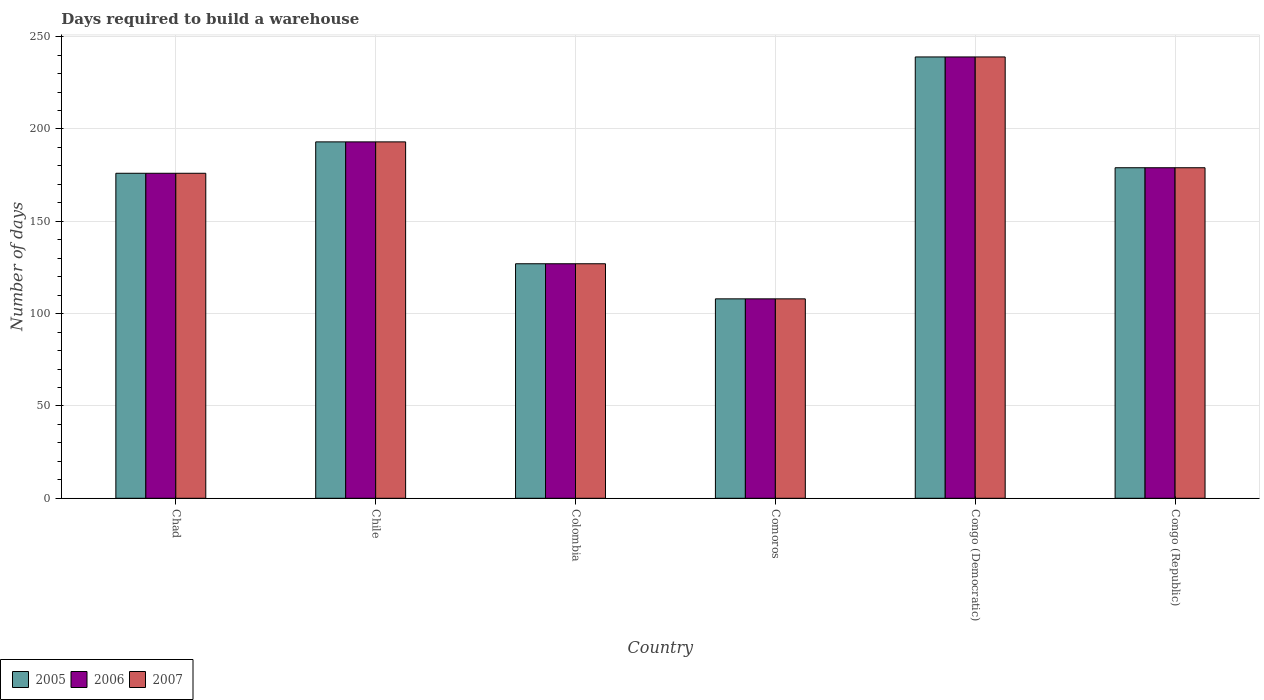How many different coloured bars are there?
Ensure brevity in your answer.  3. How many groups of bars are there?
Your response must be concise. 6. How many bars are there on the 4th tick from the left?
Your answer should be compact. 3. How many bars are there on the 6th tick from the right?
Your answer should be very brief. 3. What is the label of the 2nd group of bars from the left?
Provide a short and direct response. Chile. In how many cases, is the number of bars for a given country not equal to the number of legend labels?
Your response must be concise. 0. What is the days required to build a warehouse in in 2006 in Chile?
Keep it short and to the point. 193. Across all countries, what is the maximum days required to build a warehouse in in 2006?
Provide a succinct answer. 239. Across all countries, what is the minimum days required to build a warehouse in in 2005?
Provide a succinct answer. 108. In which country was the days required to build a warehouse in in 2007 maximum?
Give a very brief answer. Congo (Democratic). In which country was the days required to build a warehouse in in 2006 minimum?
Offer a terse response. Comoros. What is the total days required to build a warehouse in in 2005 in the graph?
Your answer should be compact. 1022. What is the difference between the days required to build a warehouse in in 2007 in Congo (Republic) and the days required to build a warehouse in in 2005 in Congo (Democratic)?
Provide a succinct answer. -60. What is the average days required to build a warehouse in in 2005 per country?
Provide a succinct answer. 170.33. What is the difference between the days required to build a warehouse in of/in 2007 and days required to build a warehouse in of/in 2006 in Colombia?
Give a very brief answer. 0. What is the ratio of the days required to build a warehouse in in 2006 in Chad to that in Colombia?
Your answer should be compact. 1.39. Is the days required to build a warehouse in in 2005 in Colombia less than that in Congo (Republic)?
Give a very brief answer. Yes. What is the difference between the highest and the lowest days required to build a warehouse in in 2006?
Your response must be concise. 131. In how many countries, is the days required to build a warehouse in in 2005 greater than the average days required to build a warehouse in in 2005 taken over all countries?
Offer a very short reply. 4. What does the 3rd bar from the left in Chile represents?
Offer a very short reply. 2007. What does the 3rd bar from the right in Chile represents?
Your response must be concise. 2005. Are all the bars in the graph horizontal?
Offer a terse response. No. Where does the legend appear in the graph?
Make the answer very short. Bottom left. How are the legend labels stacked?
Make the answer very short. Horizontal. What is the title of the graph?
Provide a succinct answer. Days required to build a warehouse. Does "2002" appear as one of the legend labels in the graph?
Keep it short and to the point. No. What is the label or title of the Y-axis?
Provide a succinct answer. Number of days. What is the Number of days of 2005 in Chad?
Offer a terse response. 176. What is the Number of days in 2006 in Chad?
Provide a short and direct response. 176. What is the Number of days in 2007 in Chad?
Provide a short and direct response. 176. What is the Number of days in 2005 in Chile?
Provide a short and direct response. 193. What is the Number of days in 2006 in Chile?
Ensure brevity in your answer.  193. What is the Number of days in 2007 in Chile?
Your answer should be very brief. 193. What is the Number of days in 2005 in Colombia?
Offer a very short reply. 127. What is the Number of days of 2006 in Colombia?
Make the answer very short. 127. What is the Number of days of 2007 in Colombia?
Your answer should be very brief. 127. What is the Number of days of 2005 in Comoros?
Your answer should be compact. 108. What is the Number of days in 2006 in Comoros?
Your answer should be very brief. 108. What is the Number of days of 2007 in Comoros?
Your response must be concise. 108. What is the Number of days in 2005 in Congo (Democratic)?
Make the answer very short. 239. What is the Number of days in 2006 in Congo (Democratic)?
Offer a very short reply. 239. What is the Number of days in 2007 in Congo (Democratic)?
Provide a short and direct response. 239. What is the Number of days of 2005 in Congo (Republic)?
Your answer should be very brief. 179. What is the Number of days of 2006 in Congo (Republic)?
Your answer should be compact. 179. What is the Number of days in 2007 in Congo (Republic)?
Make the answer very short. 179. Across all countries, what is the maximum Number of days in 2005?
Provide a succinct answer. 239. Across all countries, what is the maximum Number of days of 2006?
Your response must be concise. 239. Across all countries, what is the maximum Number of days of 2007?
Provide a succinct answer. 239. Across all countries, what is the minimum Number of days of 2005?
Provide a succinct answer. 108. Across all countries, what is the minimum Number of days of 2006?
Provide a short and direct response. 108. Across all countries, what is the minimum Number of days in 2007?
Your response must be concise. 108. What is the total Number of days in 2005 in the graph?
Provide a succinct answer. 1022. What is the total Number of days of 2006 in the graph?
Make the answer very short. 1022. What is the total Number of days of 2007 in the graph?
Offer a terse response. 1022. What is the difference between the Number of days in 2006 in Chad and that in Chile?
Provide a succinct answer. -17. What is the difference between the Number of days of 2006 in Chad and that in Colombia?
Make the answer very short. 49. What is the difference between the Number of days in 2005 in Chad and that in Congo (Democratic)?
Provide a succinct answer. -63. What is the difference between the Number of days in 2006 in Chad and that in Congo (Democratic)?
Your answer should be compact. -63. What is the difference between the Number of days in 2007 in Chad and that in Congo (Democratic)?
Offer a very short reply. -63. What is the difference between the Number of days of 2005 in Chad and that in Congo (Republic)?
Offer a terse response. -3. What is the difference between the Number of days of 2006 in Chad and that in Congo (Republic)?
Your answer should be very brief. -3. What is the difference between the Number of days of 2007 in Chad and that in Congo (Republic)?
Offer a terse response. -3. What is the difference between the Number of days in 2006 in Chile and that in Colombia?
Offer a very short reply. 66. What is the difference between the Number of days of 2006 in Chile and that in Comoros?
Make the answer very short. 85. What is the difference between the Number of days of 2005 in Chile and that in Congo (Democratic)?
Ensure brevity in your answer.  -46. What is the difference between the Number of days in 2006 in Chile and that in Congo (Democratic)?
Your answer should be compact. -46. What is the difference between the Number of days in 2007 in Chile and that in Congo (Democratic)?
Your response must be concise. -46. What is the difference between the Number of days of 2006 in Chile and that in Congo (Republic)?
Provide a succinct answer. 14. What is the difference between the Number of days of 2005 in Colombia and that in Congo (Democratic)?
Make the answer very short. -112. What is the difference between the Number of days in 2006 in Colombia and that in Congo (Democratic)?
Keep it short and to the point. -112. What is the difference between the Number of days of 2007 in Colombia and that in Congo (Democratic)?
Provide a succinct answer. -112. What is the difference between the Number of days in 2005 in Colombia and that in Congo (Republic)?
Ensure brevity in your answer.  -52. What is the difference between the Number of days in 2006 in Colombia and that in Congo (Republic)?
Keep it short and to the point. -52. What is the difference between the Number of days of 2007 in Colombia and that in Congo (Republic)?
Your answer should be compact. -52. What is the difference between the Number of days of 2005 in Comoros and that in Congo (Democratic)?
Offer a very short reply. -131. What is the difference between the Number of days in 2006 in Comoros and that in Congo (Democratic)?
Your answer should be very brief. -131. What is the difference between the Number of days in 2007 in Comoros and that in Congo (Democratic)?
Ensure brevity in your answer.  -131. What is the difference between the Number of days of 2005 in Comoros and that in Congo (Republic)?
Your response must be concise. -71. What is the difference between the Number of days in 2006 in Comoros and that in Congo (Republic)?
Offer a terse response. -71. What is the difference between the Number of days in 2007 in Comoros and that in Congo (Republic)?
Keep it short and to the point. -71. What is the difference between the Number of days of 2005 in Congo (Democratic) and that in Congo (Republic)?
Keep it short and to the point. 60. What is the difference between the Number of days in 2007 in Congo (Democratic) and that in Congo (Republic)?
Make the answer very short. 60. What is the difference between the Number of days of 2005 in Chad and the Number of days of 2007 in Chile?
Offer a terse response. -17. What is the difference between the Number of days in 2005 in Chad and the Number of days in 2007 in Colombia?
Make the answer very short. 49. What is the difference between the Number of days in 2006 in Chad and the Number of days in 2007 in Colombia?
Give a very brief answer. 49. What is the difference between the Number of days in 2005 in Chad and the Number of days in 2006 in Congo (Democratic)?
Your response must be concise. -63. What is the difference between the Number of days in 2005 in Chad and the Number of days in 2007 in Congo (Democratic)?
Offer a very short reply. -63. What is the difference between the Number of days in 2006 in Chad and the Number of days in 2007 in Congo (Democratic)?
Your answer should be compact. -63. What is the difference between the Number of days of 2005 in Chile and the Number of days of 2006 in Colombia?
Make the answer very short. 66. What is the difference between the Number of days in 2005 in Chile and the Number of days in 2007 in Colombia?
Offer a terse response. 66. What is the difference between the Number of days of 2005 in Chile and the Number of days of 2006 in Comoros?
Provide a short and direct response. 85. What is the difference between the Number of days in 2006 in Chile and the Number of days in 2007 in Comoros?
Offer a very short reply. 85. What is the difference between the Number of days of 2005 in Chile and the Number of days of 2006 in Congo (Democratic)?
Give a very brief answer. -46. What is the difference between the Number of days in 2005 in Chile and the Number of days in 2007 in Congo (Democratic)?
Keep it short and to the point. -46. What is the difference between the Number of days in 2006 in Chile and the Number of days in 2007 in Congo (Democratic)?
Provide a short and direct response. -46. What is the difference between the Number of days of 2005 in Chile and the Number of days of 2007 in Congo (Republic)?
Offer a terse response. 14. What is the difference between the Number of days of 2005 in Colombia and the Number of days of 2006 in Comoros?
Give a very brief answer. 19. What is the difference between the Number of days of 2005 in Colombia and the Number of days of 2007 in Comoros?
Provide a short and direct response. 19. What is the difference between the Number of days in 2006 in Colombia and the Number of days in 2007 in Comoros?
Provide a succinct answer. 19. What is the difference between the Number of days in 2005 in Colombia and the Number of days in 2006 in Congo (Democratic)?
Keep it short and to the point. -112. What is the difference between the Number of days in 2005 in Colombia and the Number of days in 2007 in Congo (Democratic)?
Provide a succinct answer. -112. What is the difference between the Number of days in 2006 in Colombia and the Number of days in 2007 in Congo (Democratic)?
Ensure brevity in your answer.  -112. What is the difference between the Number of days in 2005 in Colombia and the Number of days in 2006 in Congo (Republic)?
Make the answer very short. -52. What is the difference between the Number of days of 2005 in Colombia and the Number of days of 2007 in Congo (Republic)?
Provide a short and direct response. -52. What is the difference between the Number of days of 2006 in Colombia and the Number of days of 2007 in Congo (Republic)?
Provide a short and direct response. -52. What is the difference between the Number of days in 2005 in Comoros and the Number of days in 2006 in Congo (Democratic)?
Keep it short and to the point. -131. What is the difference between the Number of days of 2005 in Comoros and the Number of days of 2007 in Congo (Democratic)?
Ensure brevity in your answer.  -131. What is the difference between the Number of days of 2006 in Comoros and the Number of days of 2007 in Congo (Democratic)?
Ensure brevity in your answer.  -131. What is the difference between the Number of days of 2005 in Comoros and the Number of days of 2006 in Congo (Republic)?
Your answer should be very brief. -71. What is the difference between the Number of days in 2005 in Comoros and the Number of days in 2007 in Congo (Republic)?
Your answer should be compact. -71. What is the difference between the Number of days in 2006 in Comoros and the Number of days in 2007 in Congo (Republic)?
Offer a terse response. -71. What is the difference between the Number of days of 2005 in Congo (Democratic) and the Number of days of 2006 in Congo (Republic)?
Keep it short and to the point. 60. What is the difference between the Number of days in 2005 in Congo (Democratic) and the Number of days in 2007 in Congo (Republic)?
Give a very brief answer. 60. What is the average Number of days in 2005 per country?
Your answer should be compact. 170.33. What is the average Number of days in 2006 per country?
Provide a succinct answer. 170.33. What is the average Number of days in 2007 per country?
Keep it short and to the point. 170.33. What is the difference between the Number of days in 2005 and Number of days in 2007 in Chad?
Your response must be concise. 0. What is the difference between the Number of days of 2005 and Number of days of 2006 in Colombia?
Your answer should be compact. 0. What is the difference between the Number of days of 2006 and Number of days of 2007 in Colombia?
Your answer should be very brief. 0. What is the difference between the Number of days in 2005 and Number of days in 2006 in Comoros?
Provide a short and direct response. 0. What is the difference between the Number of days in 2006 and Number of days in 2007 in Comoros?
Keep it short and to the point. 0. What is the difference between the Number of days of 2005 and Number of days of 2006 in Congo (Democratic)?
Give a very brief answer. 0. What is the difference between the Number of days of 2006 and Number of days of 2007 in Congo (Democratic)?
Ensure brevity in your answer.  0. What is the difference between the Number of days in 2005 and Number of days in 2006 in Congo (Republic)?
Provide a succinct answer. 0. What is the difference between the Number of days of 2006 and Number of days of 2007 in Congo (Republic)?
Provide a short and direct response. 0. What is the ratio of the Number of days of 2005 in Chad to that in Chile?
Provide a succinct answer. 0.91. What is the ratio of the Number of days in 2006 in Chad to that in Chile?
Offer a terse response. 0.91. What is the ratio of the Number of days of 2007 in Chad to that in Chile?
Your answer should be very brief. 0.91. What is the ratio of the Number of days in 2005 in Chad to that in Colombia?
Your answer should be very brief. 1.39. What is the ratio of the Number of days in 2006 in Chad to that in Colombia?
Offer a terse response. 1.39. What is the ratio of the Number of days in 2007 in Chad to that in Colombia?
Your answer should be compact. 1.39. What is the ratio of the Number of days in 2005 in Chad to that in Comoros?
Make the answer very short. 1.63. What is the ratio of the Number of days of 2006 in Chad to that in Comoros?
Provide a short and direct response. 1.63. What is the ratio of the Number of days in 2007 in Chad to that in Comoros?
Provide a succinct answer. 1.63. What is the ratio of the Number of days of 2005 in Chad to that in Congo (Democratic)?
Offer a terse response. 0.74. What is the ratio of the Number of days of 2006 in Chad to that in Congo (Democratic)?
Ensure brevity in your answer.  0.74. What is the ratio of the Number of days in 2007 in Chad to that in Congo (Democratic)?
Your response must be concise. 0.74. What is the ratio of the Number of days of 2005 in Chad to that in Congo (Republic)?
Offer a very short reply. 0.98. What is the ratio of the Number of days in 2006 in Chad to that in Congo (Republic)?
Your answer should be compact. 0.98. What is the ratio of the Number of days in 2007 in Chad to that in Congo (Republic)?
Ensure brevity in your answer.  0.98. What is the ratio of the Number of days in 2005 in Chile to that in Colombia?
Provide a succinct answer. 1.52. What is the ratio of the Number of days of 2006 in Chile to that in Colombia?
Ensure brevity in your answer.  1.52. What is the ratio of the Number of days of 2007 in Chile to that in Colombia?
Provide a succinct answer. 1.52. What is the ratio of the Number of days in 2005 in Chile to that in Comoros?
Offer a very short reply. 1.79. What is the ratio of the Number of days of 2006 in Chile to that in Comoros?
Your answer should be compact. 1.79. What is the ratio of the Number of days in 2007 in Chile to that in Comoros?
Make the answer very short. 1.79. What is the ratio of the Number of days in 2005 in Chile to that in Congo (Democratic)?
Your answer should be compact. 0.81. What is the ratio of the Number of days in 2006 in Chile to that in Congo (Democratic)?
Make the answer very short. 0.81. What is the ratio of the Number of days of 2007 in Chile to that in Congo (Democratic)?
Make the answer very short. 0.81. What is the ratio of the Number of days of 2005 in Chile to that in Congo (Republic)?
Offer a terse response. 1.08. What is the ratio of the Number of days in 2006 in Chile to that in Congo (Republic)?
Ensure brevity in your answer.  1.08. What is the ratio of the Number of days of 2007 in Chile to that in Congo (Republic)?
Offer a very short reply. 1.08. What is the ratio of the Number of days of 2005 in Colombia to that in Comoros?
Offer a very short reply. 1.18. What is the ratio of the Number of days in 2006 in Colombia to that in Comoros?
Provide a succinct answer. 1.18. What is the ratio of the Number of days in 2007 in Colombia to that in Comoros?
Your answer should be compact. 1.18. What is the ratio of the Number of days of 2005 in Colombia to that in Congo (Democratic)?
Keep it short and to the point. 0.53. What is the ratio of the Number of days of 2006 in Colombia to that in Congo (Democratic)?
Keep it short and to the point. 0.53. What is the ratio of the Number of days in 2007 in Colombia to that in Congo (Democratic)?
Your answer should be compact. 0.53. What is the ratio of the Number of days of 2005 in Colombia to that in Congo (Republic)?
Make the answer very short. 0.71. What is the ratio of the Number of days in 2006 in Colombia to that in Congo (Republic)?
Your response must be concise. 0.71. What is the ratio of the Number of days of 2007 in Colombia to that in Congo (Republic)?
Your answer should be compact. 0.71. What is the ratio of the Number of days of 2005 in Comoros to that in Congo (Democratic)?
Give a very brief answer. 0.45. What is the ratio of the Number of days of 2006 in Comoros to that in Congo (Democratic)?
Provide a short and direct response. 0.45. What is the ratio of the Number of days of 2007 in Comoros to that in Congo (Democratic)?
Your answer should be compact. 0.45. What is the ratio of the Number of days in 2005 in Comoros to that in Congo (Republic)?
Your answer should be very brief. 0.6. What is the ratio of the Number of days of 2006 in Comoros to that in Congo (Republic)?
Your response must be concise. 0.6. What is the ratio of the Number of days in 2007 in Comoros to that in Congo (Republic)?
Provide a short and direct response. 0.6. What is the ratio of the Number of days in 2005 in Congo (Democratic) to that in Congo (Republic)?
Keep it short and to the point. 1.34. What is the ratio of the Number of days of 2006 in Congo (Democratic) to that in Congo (Republic)?
Your response must be concise. 1.34. What is the ratio of the Number of days in 2007 in Congo (Democratic) to that in Congo (Republic)?
Offer a very short reply. 1.34. What is the difference between the highest and the second highest Number of days in 2006?
Offer a terse response. 46. What is the difference between the highest and the lowest Number of days in 2005?
Offer a very short reply. 131. What is the difference between the highest and the lowest Number of days of 2006?
Make the answer very short. 131. What is the difference between the highest and the lowest Number of days of 2007?
Keep it short and to the point. 131. 